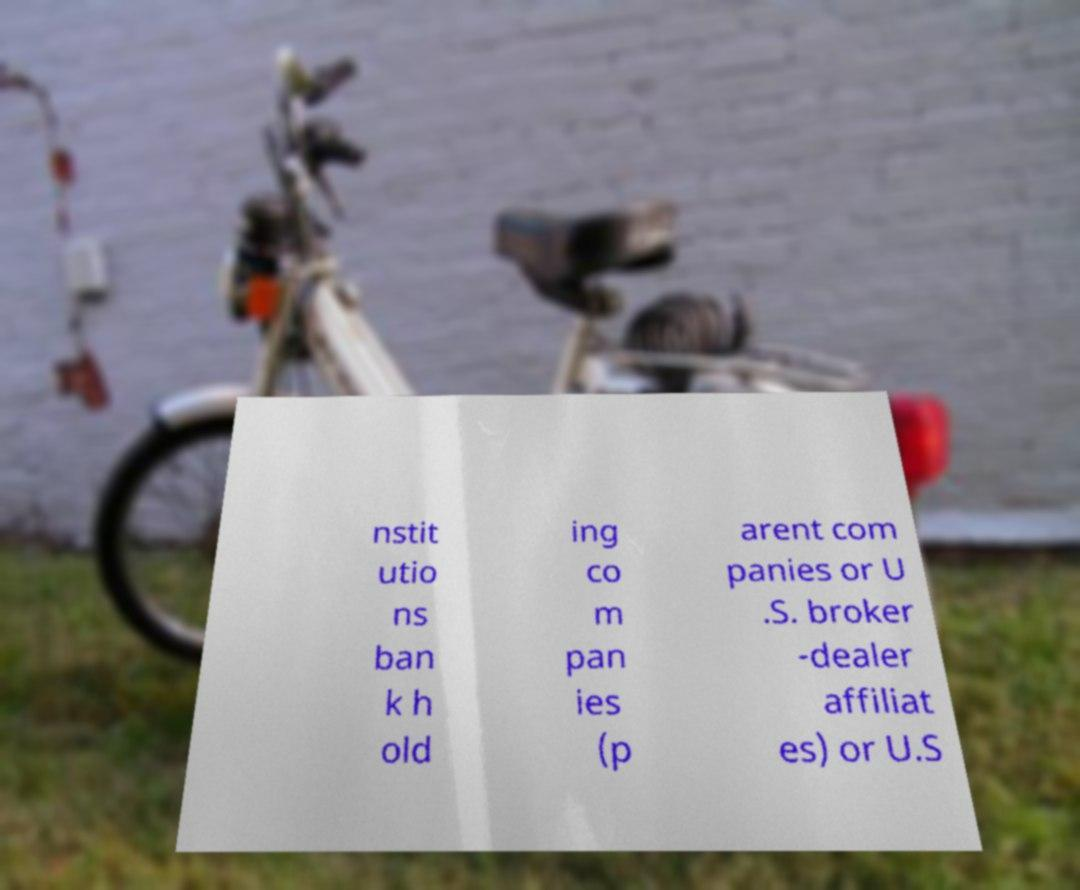What messages or text are displayed in this image? I need them in a readable, typed format. nstit utio ns ban k h old ing co m pan ies (p arent com panies or U .S. broker -dealer affiliat es) or U.S 